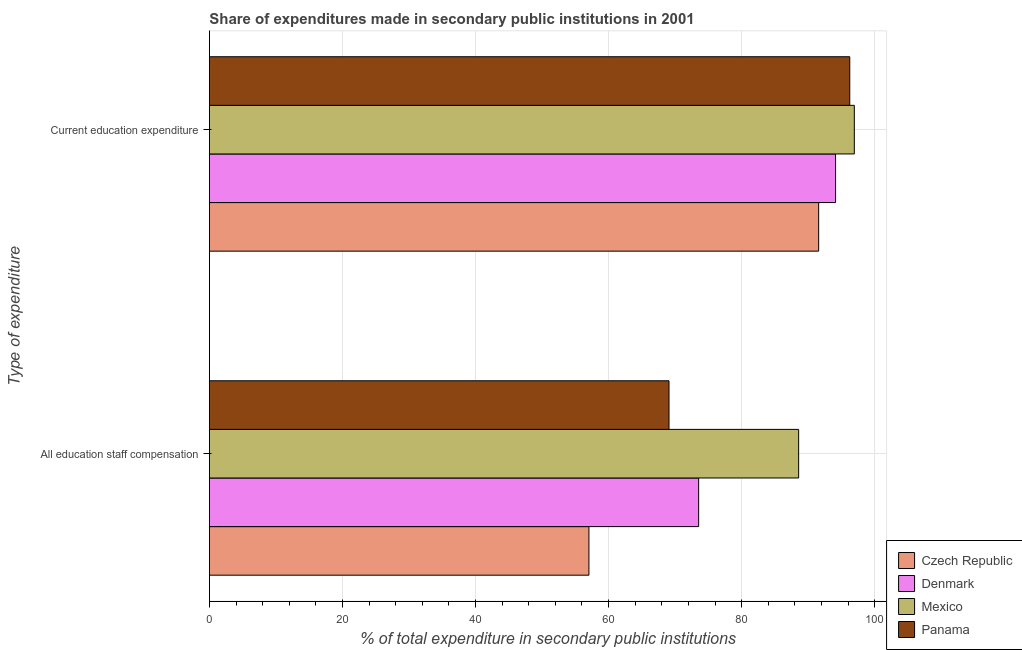Are the number of bars on each tick of the Y-axis equal?
Provide a succinct answer. Yes. How many bars are there on the 2nd tick from the top?
Keep it short and to the point. 4. How many bars are there on the 1st tick from the bottom?
Give a very brief answer. 4. What is the label of the 1st group of bars from the top?
Give a very brief answer. Current education expenditure. What is the expenditure in education in Denmark?
Keep it short and to the point. 94.12. Across all countries, what is the maximum expenditure in staff compensation?
Ensure brevity in your answer.  88.57. Across all countries, what is the minimum expenditure in staff compensation?
Offer a terse response. 57.05. In which country was the expenditure in staff compensation minimum?
Give a very brief answer. Czech Republic. What is the total expenditure in staff compensation in the graph?
Make the answer very short. 288.25. What is the difference between the expenditure in staff compensation in Czech Republic and that in Panama?
Offer a very short reply. -12.04. What is the difference between the expenditure in education in Denmark and the expenditure in staff compensation in Panama?
Your response must be concise. 25.04. What is the average expenditure in staff compensation per country?
Give a very brief answer. 72.06. What is the difference between the expenditure in education and expenditure in staff compensation in Mexico?
Your answer should be very brief. 8.37. In how many countries, is the expenditure in staff compensation greater than 84 %?
Give a very brief answer. 1. What is the ratio of the expenditure in staff compensation in Panama to that in Czech Republic?
Offer a very short reply. 1.21. In how many countries, is the expenditure in education greater than the average expenditure in education taken over all countries?
Your answer should be compact. 2. What does the 1st bar from the top in All education staff compensation represents?
Make the answer very short. Panama. What does the 4th bar from the bottom in Current education expenditure represents?
Make the answer very short. Panama. Are all the bars in the graph horizontal?
Make the answer very short. Yes. What is the difference between two consecutive major ticks on the X-axis?
Give a very brief answer. 20. Are the values on the major ticks of X-axis written in scientific E-notation?
Make the answer very short. No. Does the graph contain any zero values?
Ensure brevity in your answer.  No. Does the graph contain grids?
Provide a succinct answer. Yes. What is the title of the graph?
Keep it short and to the point. Share of expenditures made in secondary public institutions in 2001. What is the label or title of the X-axis?
Ensure brevity in your answer.  % of total expenditure in secondary public institutions. What is the label or title of the Y-axis?
Your response must be concise. Type of expenditure. What is the % of total expenditure in secondary public institutions of Czech Republic in All education staff compensation?
Your answer should be compact. 57.05. What is the % of total expenditure in secondary public institutions of Denmark in All education staff compensation?
Keep it short and to the point. 73.54. What is the % of total expenditure in secondary public institutions of Mexico in All education staff compensation?
Make the answer very short. 88.57. What is the % of total expenditure in secondary public institutions in Panama in All education staff compensation?
Your answer should be compact. 69.09. What is the % of total expenditure in secondary public institutions of Czech Republic in Current education expenditure?
Make the answer very short. 91.58. What is the % of total expenditure in secondary public institutions in Denmark in Current education expenditure?
Keep it short and to the point. 94.12. What is the % of total expenditure in secondary public institutions in Mexico in Current education expenditure?
Provide a short and direct response. 96.94. What is the % of total expenditure in secondary public institutions of Panama in Current education expenditure?
Make the answer very short. 96.26. Across all Type of expenditure, what is the maximum % of total expenditure in secondary public institutions in Czech Republic?
Your answer should be compact. 91.58. Across all Type of expenditure, what is the maximum % of total expenditure in secondary public institutions in Denmark?
Keep it short and to the point. 94.12. Across all Type of expenditure, what is the maximum % of total expenditure in secondary public institutions of Mexico?
Ensure brevity in your answer.  96.94. Across all Type of expenditure, what is the maximum % of total expenditure in secondary public institutions of Panama?
Keep it short and to the point. 96.26. Across all Type of expenditure, what is the minimum % of total expenditure in secondary public institutions of Czech Republic?
Keep it short and to the point. 57.05. Across all Type of expenditure, what is the minimum % of total expenditure in secondary public institutions of Denmark?
Make the answer very short. 73.54. Across all Type of expenditure, what is the minimum % of total expenditure in secondary public institutions in Mexico?
Your response must be concise. 88.57. Across all Type of expenditure, what is the minimum % of total expenditure in secondary public institutions of Panama?
Offer a very short reply. 69.09. What is the total % of total expenditure in secondary public institutions in Czech Republic in the graph?
Your response must be concise. 148.63. What is the total % of total expenditure in secondary public institutions in Denmark in the graph?
Offer a terse response. 167.66. What is the total % of total expenditure in secondary public institutions in Mexico in the graph?
Give a very brief answer. 185.52. What is the total % of total expenditure in secondary public institutions of Panama in the graph?
Ensure brevity in your answer.  165.35. What is the difference between the % of total expenditure in secondary public institutions of Czech Republic in All education staff compensation and that in Current education expenditure?
Provide a succinct answer. -34.53. What is the difference between the % of total expenditure in secondary public institutions of Denmark in All education staff compensation and that in Current education expenditure?
Your response must be concise. -20.58. What is the difference between the % of total expenditure in secondary public institutions of Mexico in All education staff compensation and that in Current education expenditure?
Your answer should be compact. -8.37. What is the difference between the % of total expenditure in secondary public institutions of Panama in All education staff compensation and that in Current education expenditure?
Keep it short and to the point. -27.17. What is the difference between the % of total expenditure in secondary public institutions of Czech Republic in All education staff compensation and the % of total expenditure in secondary public institutions of Denmark in Current education expenditure?
Make the answer very short. -37.07. What is the difference between the % of total expenditure in secondary public institutions in Czech Republic in All education staff compensation and the % of total expenditure in secondary public institutions in Mexico in Current education expenditure?
Provide a succinct answer. -39.9. What is the difference between the % of total expenditure in secondary public institutions of Czech Republic in All education staff compensation and the % of total expenditure in secondary public institutions of Panama in Current education expenditure?
Offer a terse response. -39.21. What is the difference between the % of total expenditure in secondary public institutions in Denmark in All education staff compensation and the % of total expenditure in secondary public institutions in Mexico in Current education expenditure?
Provide a succinct answer. -23.4. What is the difference between the % of total expenditure in secondary public institutions of Denmark in All education staff compensation and the % of total expenditure in secondary public institutions of Panama in Current education expenditure?
Ensure brevity in your answer.  -22.72. What is the difference between the % of total expenditure in secondary public institutions of Mexico in All education staff compensation and the % of total expenditure in secondary public institutions of Panama in Current education expenditure?
Provide a short and direct response. -7.69. What is the average % of total expenditure in secondary public institutions of Czech Republic per Type of expenditure?
Provide a short and direct response. 74.31. What is the average % of total expenditure in secondary public institutions of Denmark per Type of expenditure?
Your answer should be compact. 83.83. What is the average % of total expenditure in secondary public institutions of Mexico per Type of expenditure?
Give a very brief answer. 92.76. What is the average % of total expenditure in secondary public institutions in Panama per Type of expenditure?
Keep it short and to the point. 82.67. What is the difference between the % of total expenditure in secondary public institutions in Czech Republic and % of total expenditure in secondary public institutions in Denmark in All education staff compensation?
Your answer should be compact. -16.49. What is the difference between the % of total expenditure in secondary public institutions in Czech Republic and % of total expenditure in secondary public institutions in Mexico in All education staff compensation?
Offer a terse response. -31.52. What is the difference between the % of total expenditure in secondary public institutions in Czech Republic and % of total expenditure in secondary public institutions in Panama in All education staff compensation?
Provide a short and direct response. -12.04. What is the difference between the % of total expenditure in secondary public institutions in Denmark and % of total expenditure in secondary public institutions in Mexico in All education staff compensation?
Provide a short and direct response. -15.03. What is the difference between the % of total expenditure in secondary public institutions of Denmark and % of total expenditure in secondary public institutions of Panama in All education staff compensation?
Your response must be concise. 4.46. What is the difference between the % of total expenditure in secondary public institutions in Mexico and % of total expenditure in secondary public institutions in Panama in All education staff compensation?
Give a very brief answer. 19.49. What is the difference between the % of total expenditure in secondary public institutions in Czech Republic and % of total expenditure in secondary public institutions in Denmark in Current education expenditure?
Offer a terse response. -2.54. What is the difference between the % of total expenditure in secondary public institutions of Czech Republic and % of total expenditure in secondary public institutions of Mexico in Current education expenditure?
Your answer should be compact. -5.36. What is the difference between the % of total expenditure in secondary public institutions of Czech Republic and % of total expenditure in secondary public institutions of Panama in Current education expenditure?
Make the answer very short. -4.68. What is the difference between the % of total expenditure in secondary public institutions in Denmark and % of total expenditure in secondary public institutions in Mexico in Current education expenditure?
Make the answer very short. -2.82. What is the difference between the % of total expenditure in secondary public institutions of Denmark and % of total expenditure in secondary public institutions of Panama in Current education expenditure?
Give a very brief answer. -2.14. What is the difference between the % of total expenditure in secondary public institutions in Mexico and % of total expenditure in secondary public institutions in Panama in Current education expenditure?
Offer a very short reply. 0.68. What is the ratio of the % of total expenditure in secondary public institutions of Czech Republic in All education staff compensation to that in Current education expenditure?
Your answer should be compact. 0.62. What is the ratio of the % of total expenditure in secondary public institutions of Denmark in All education staff compensation to that in Current education expenditure?
Keep it short and to the point. 0.78. What is the ratio of the % of total expenditure in secondary public institutions in Mexico in All education staff compensation to that in Current education expenditure?
Provide a succinct answer. 0.91. What is the ratio of the % of total expenditure in secondary public institutions of Panama in All education staff compensation to that in Current education expenditure?
Provide a short and direct response. 0.72. What is the difference between the highest and the second highest % of total expenditure in secondary public institutions in Czech Republic?
Provide a short and direct response. 34.53. What is the difference between the highest and the second highest % of total expenditure in secondary public institutions in Denmark?
Provide a succinct answer. 20.58. What is the difference between the highest and the second highest % of total expenditure in secondary public institutions in Mexico?
Ensure brevity in your answer.  8.37. What is the difference between the highest and the second highest % of total expenditure in secondary public institutions of Panama?
Provide a short and direct response. 27.17. What is the difference between the highest and the lowest % of total expenditure in secondary public institutions in Czech Republic?
Ensure brevity in your answer.  34.53. What is the difference between the highest and the lowest % of total expenditure in secondary public institutions of Denmark?
Keep it short and to the point. 20.58. What is the difference between the highest and the lowest % of total expenditure in secondary public institutions in Mexico?
Your answer should be compact. 8.37. What is the difference between the highest and the lowest % of total expenditure in secondary public institutions in Panama?
Offer a very short reply. 27.17. 